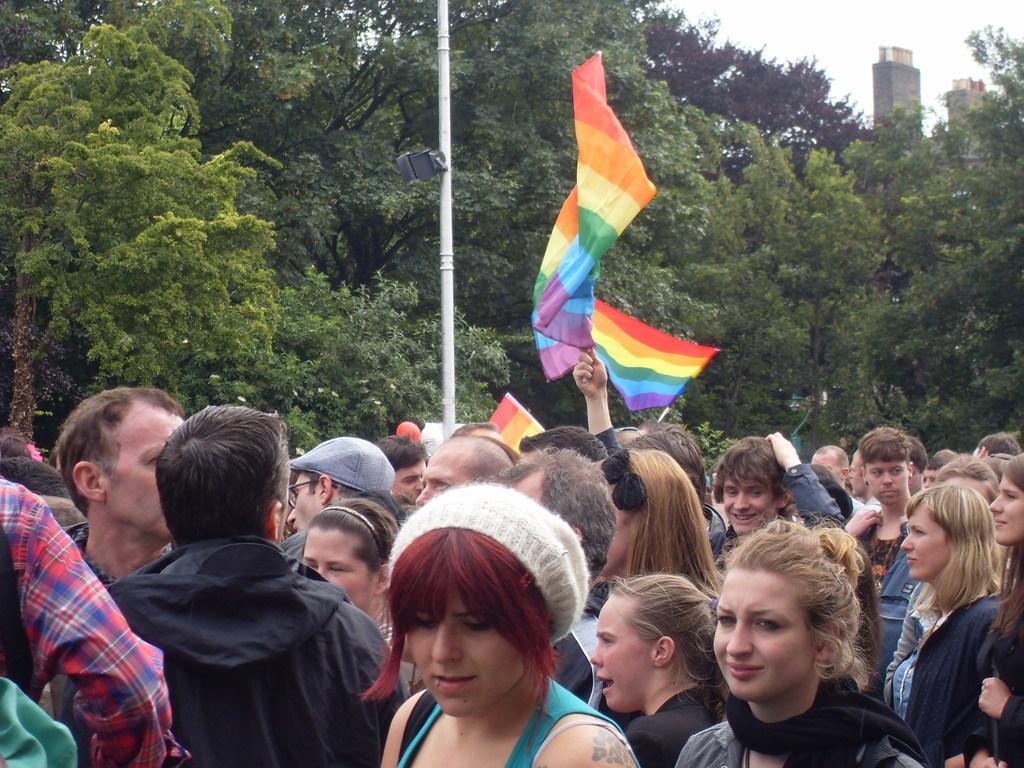How would you summarize this image in a sentence or two? In this image there are few people some are holding flags in their hands and there is a pole. In the background there are trees and buildings. 